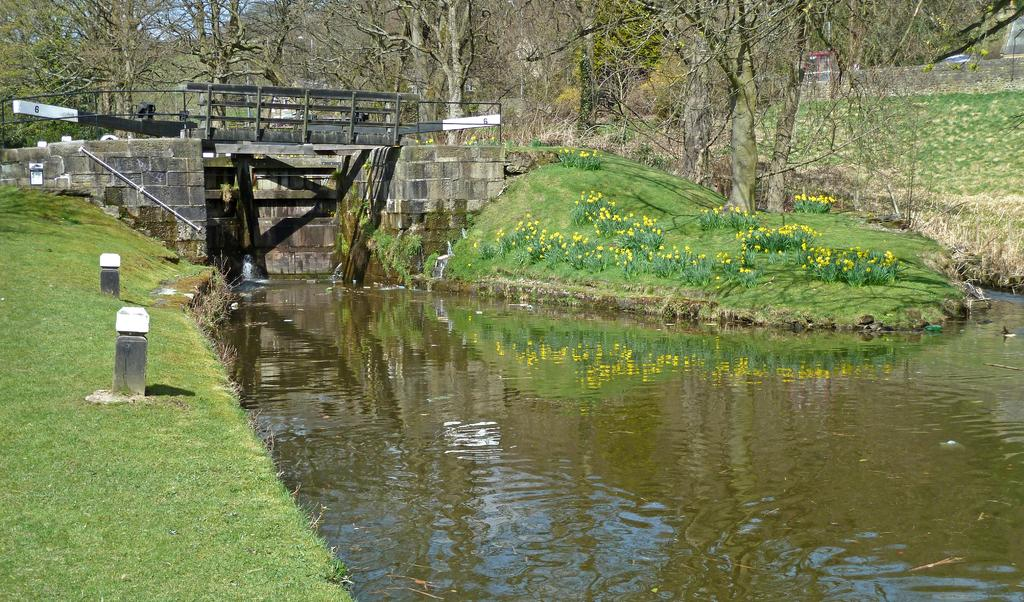What is the primary element visible in the image? There is water in the image. What type of vegetation can be seen in the image? There are plants and grass in the image. What structures are present in the image? There are poles in the image. What can be seen in the background of the image? In the background, there are trees, a bridge, and walls. What type of sink can be seen in the image? There is no sink present in the image. What is the head doing in the image? There is no head or person present in the image. 